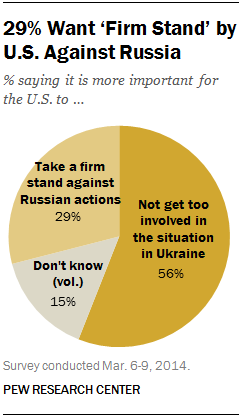Highlight a few significant elements in this photo. The percentage value of the gray segment is 15. The sum of all the segments with a percentage value smaller than 30 is 44. 